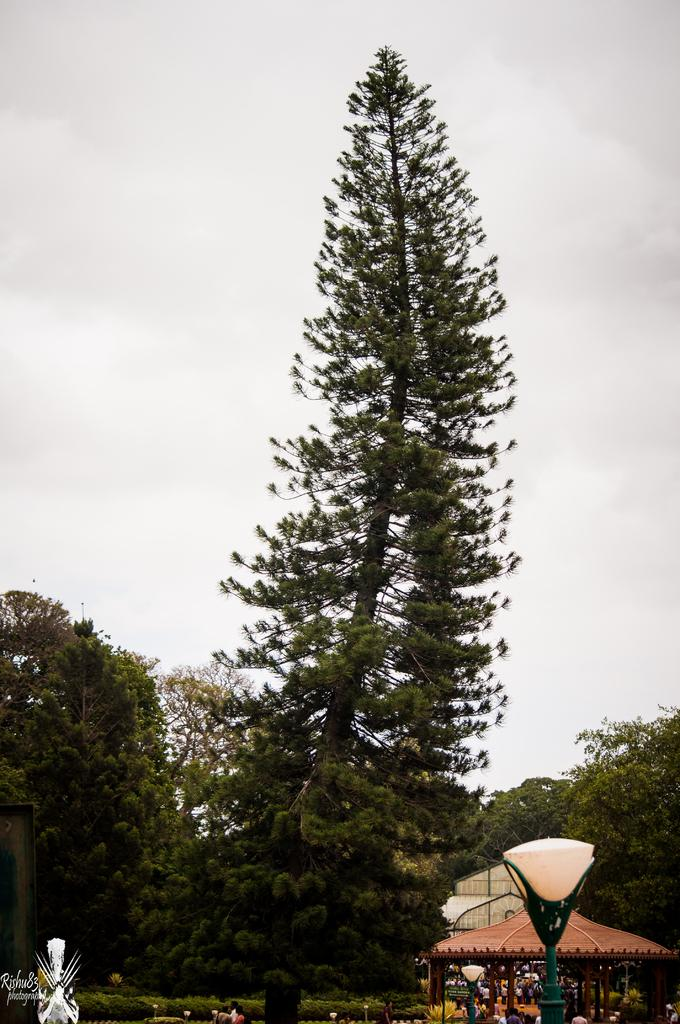What type of vegetation can be seen in the image? There are trees in the image. What structures are located near the trees? There are tents near the trees. What object is in the front of the image? There is a pole in the front of the image. What is the condition of the sky in the image? The sky is cloudy in the image. What type of brass instrument is being played by the elbow in the image? There is no brass instrument or elbow present in the image. 